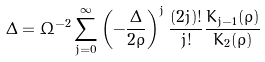Convert formula to latex. <formula><loc_0><loc_0><loc_500><loc_500>\Delta = \Omega ^ { - 2 } \sum ^ { \infty } _ { j = 0 } \left ( - \frac { \Delta } { 2 \rho } \right ) ^ { j } \frac { ( 2 j ) ! } { j ! } \frac { K _ { j - 1 } ( \rho ) } { K _ { 2 } ( \rho ) }</formula> 